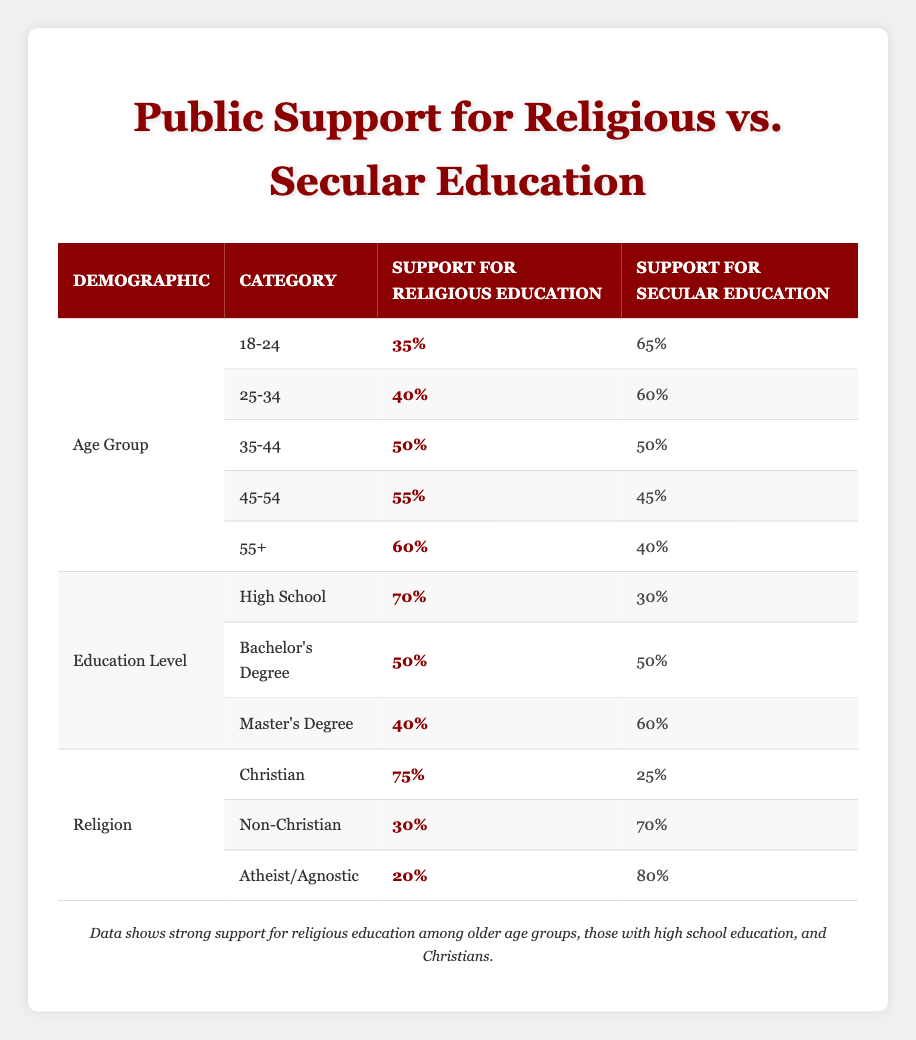What percentage of the 55+ age group supports secular education? The table states that the support for secular education in the 55+ age group is 40%.
Answer: 40% Which education level has the highest support for religious education? According to the table, the High School education level has the highest support at 70%.
Answer: High School What is the difference in support for religious education between the Age Group 25-34 and 45-54? The support for religious education in the 25-34 age group is 40%, and in the 45-54 age group, it is 55%. The difference is 55 - 40 = 15%.
Answer: 15% Do more Christians support secular education than Atheists/Agnostics? According to the data, Christians support secular education at 25%, while Atheists/Agnostics support it at 80%. Therefore, Atheists/Agnostics have higher secular support.
Answer: No What is the average support for religious education across all age groups? Adding the support percentages for each age group: 35 + 40 + 50 + 55 + 60 = 240. There are 5 age groups, so the average is 240 / 5 = 48%.
Answer: 48% What percentage of people with a Master’s Degree support secular education? According to the table, 60% of individuals with a Master’s Degree support secular education.
Answer: 60% In which demographic group do we see the most significant discrepancy between support for religious education and secular education? Analyzing the data, the highest discrepancy is in the Christian demographic, with 75% supporting religious education and 25% for secular education, leading to a 50% difference.
Answer: Christian What is the support for religious education among Non-Christians? The table shows that support for religious education among Non-Christians is 30%.
Answer: 30% What is the total support for secular education among the 18-24 and 35-44 age groups combined? The support for secular education among the 18-24 age group is 65%, and for the 35-44 age group, it is 50%. Thus, the combined support is 65 + 50 = 115%.
Answer: 115% 